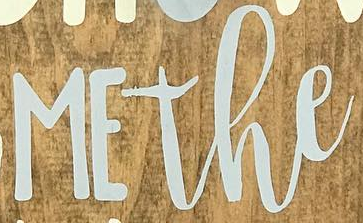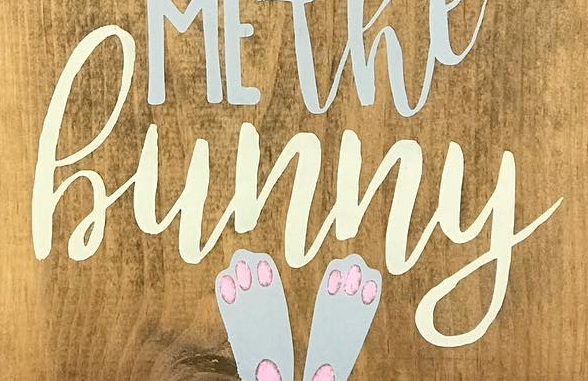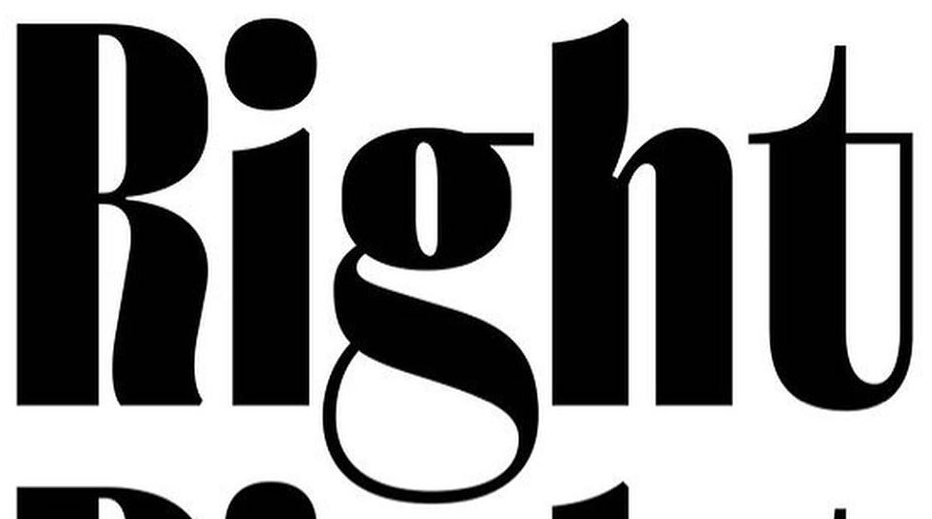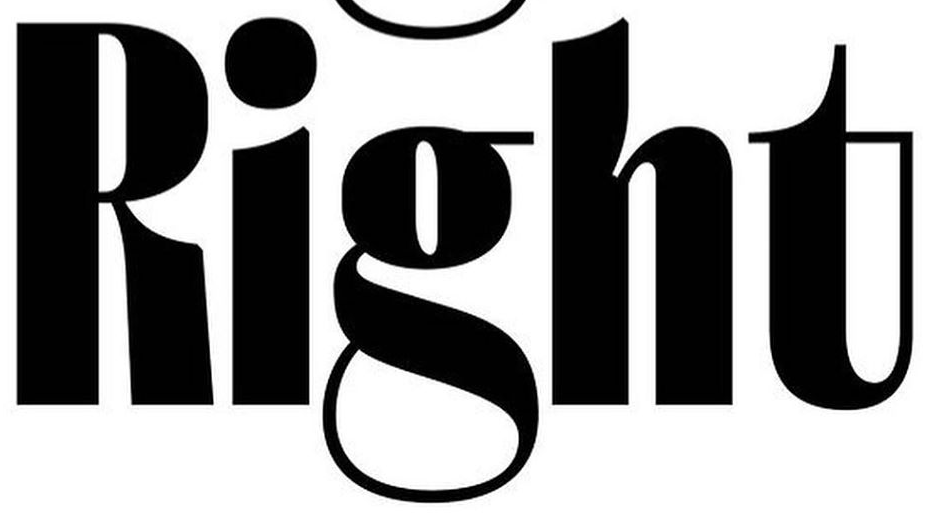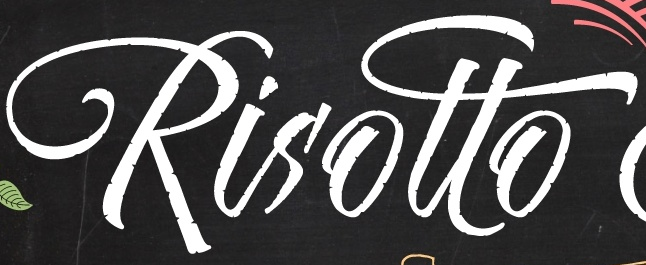Read the text from these images in sequence, separated by a semicolon. MEthe; hunny; Right; Right; Risotto 